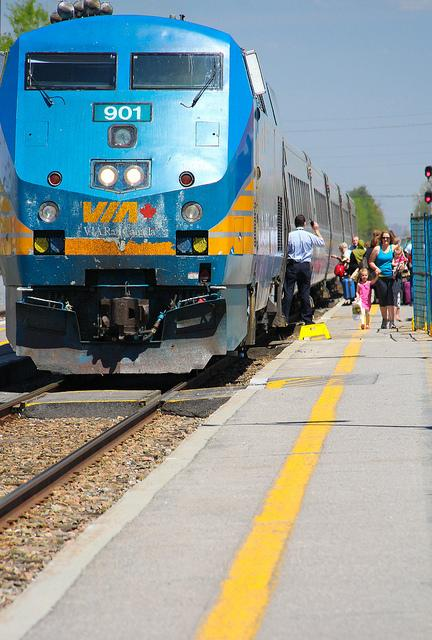What is the occupation of the man on the yellow step? Please explain your reasoning. conductor. He's the conductor. 